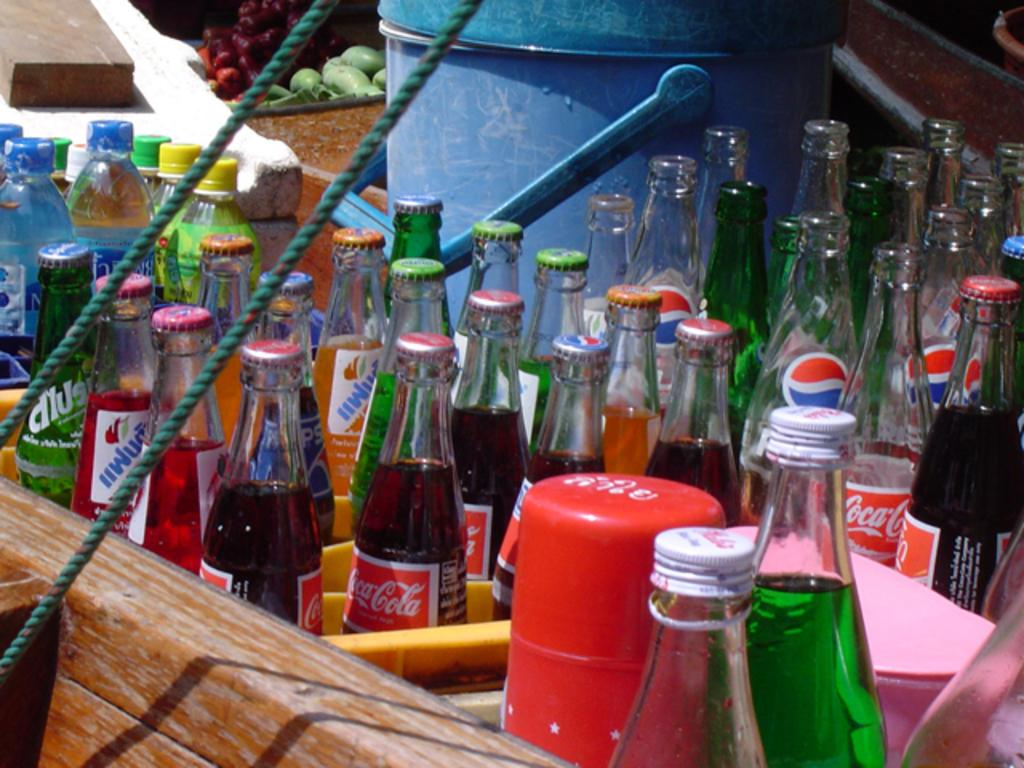Provide a one-sentence caption for the provided image. Multiple bottles of soda including pepsi and coke that are open and closed. 